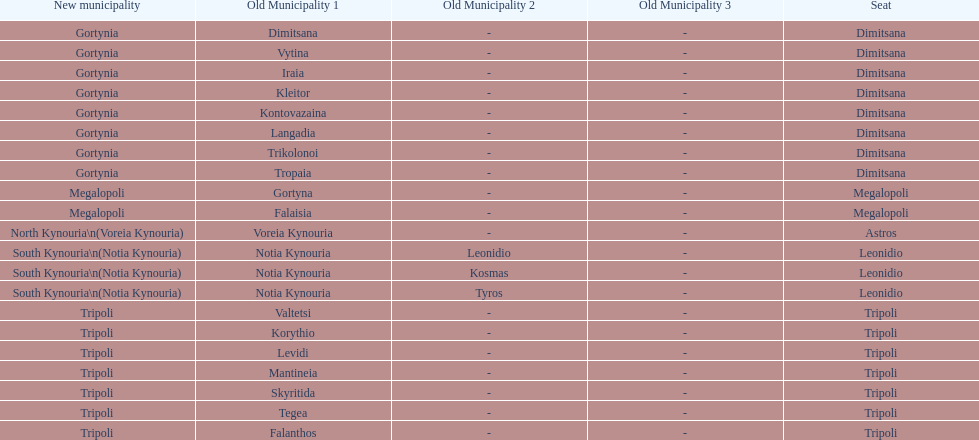What is the new municipality of tyros? South Kynouria. 